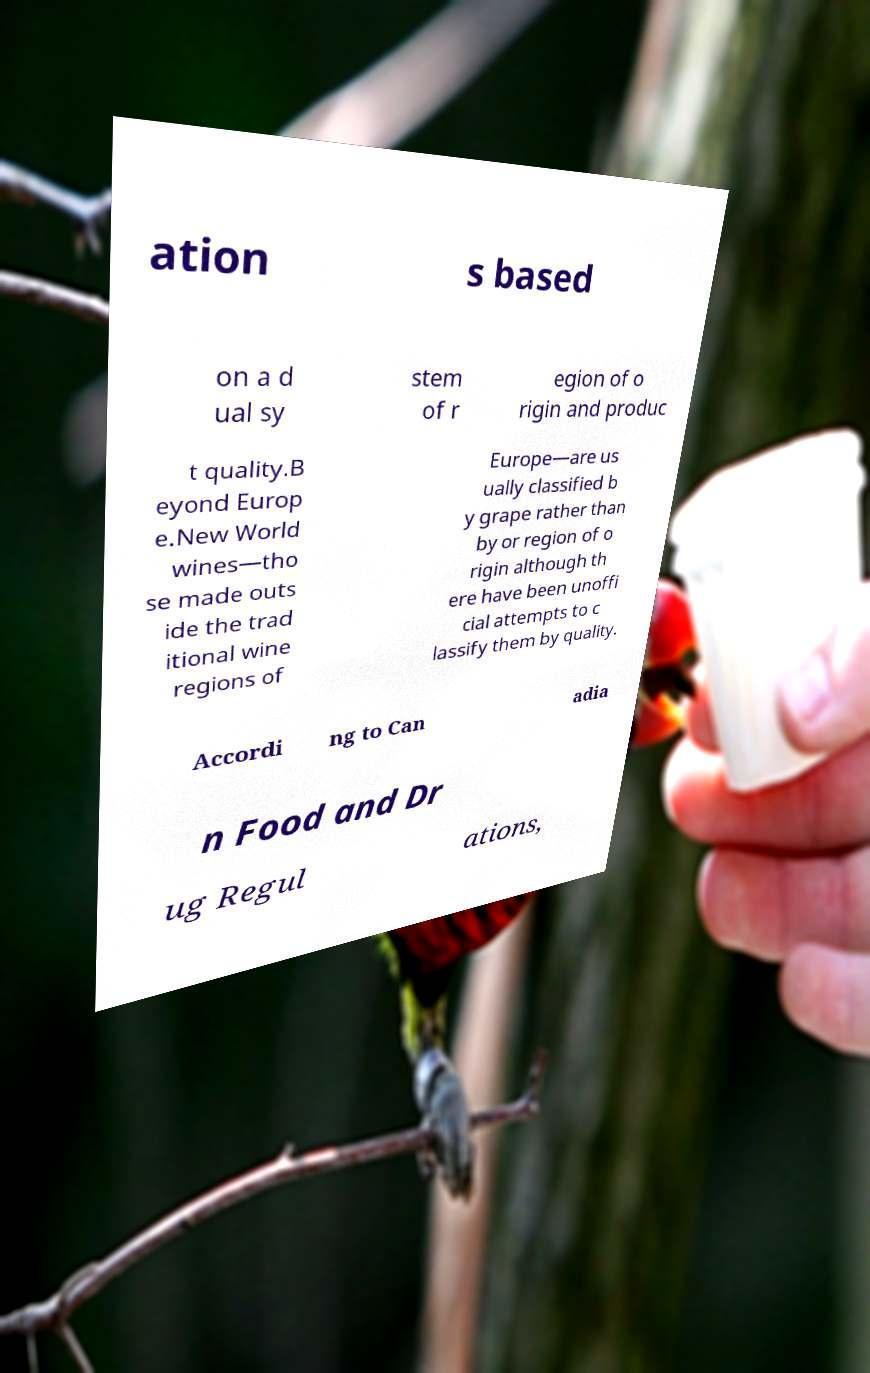For documentation purposes, I need the text within this image transcribed. Could you provide that? ation s based on a d ual sy stem of r egion of o rigin and produc t quality.B eyond Europ e.New World wines—tho se made outs ide the trad itional wine regions of Europe—are us ually classified b y grape rather than by or region of o rigin although th ere have been unoffi cial attempts to c lassify them by quality. Accordi ng to Can adia n Food and Dr ug Regul ations, 